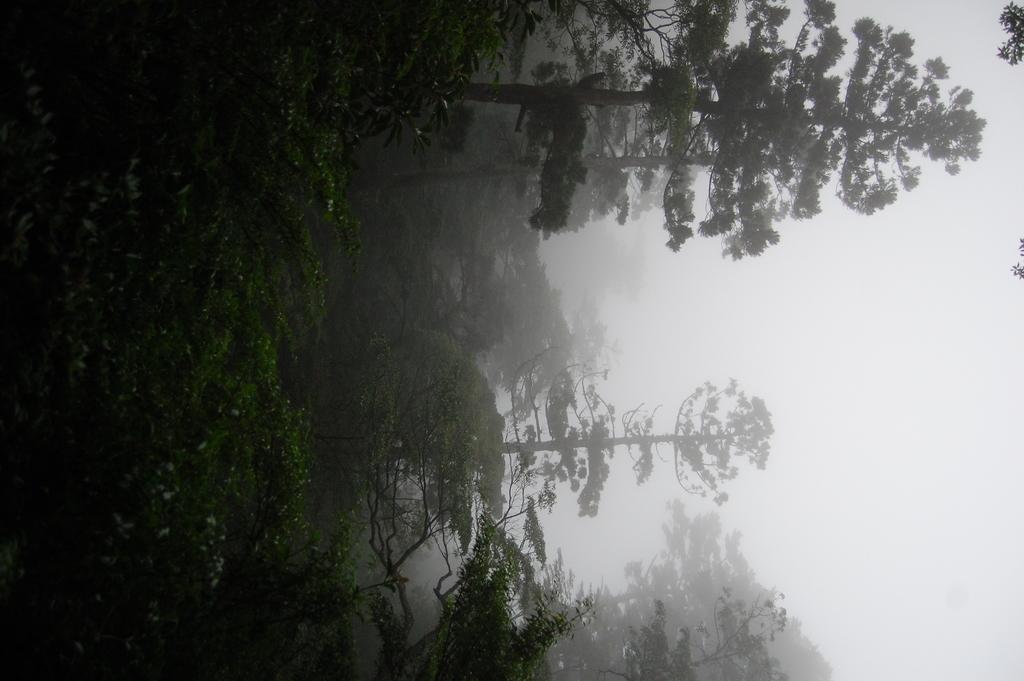How would you summarize this image in a sentence or two? In this picture we can see few trees. 